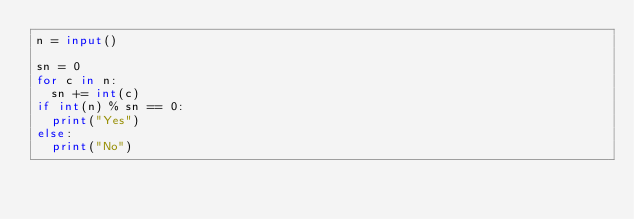Convert code to text. <code><loc_0><loc_0><loc_500><loc_500><_Python_>n = input()

sn = 0
for c in n:
  sn += int(c)
if int(n) % sn == 0:
  print("Yes")
else:
  print("No")</code> 